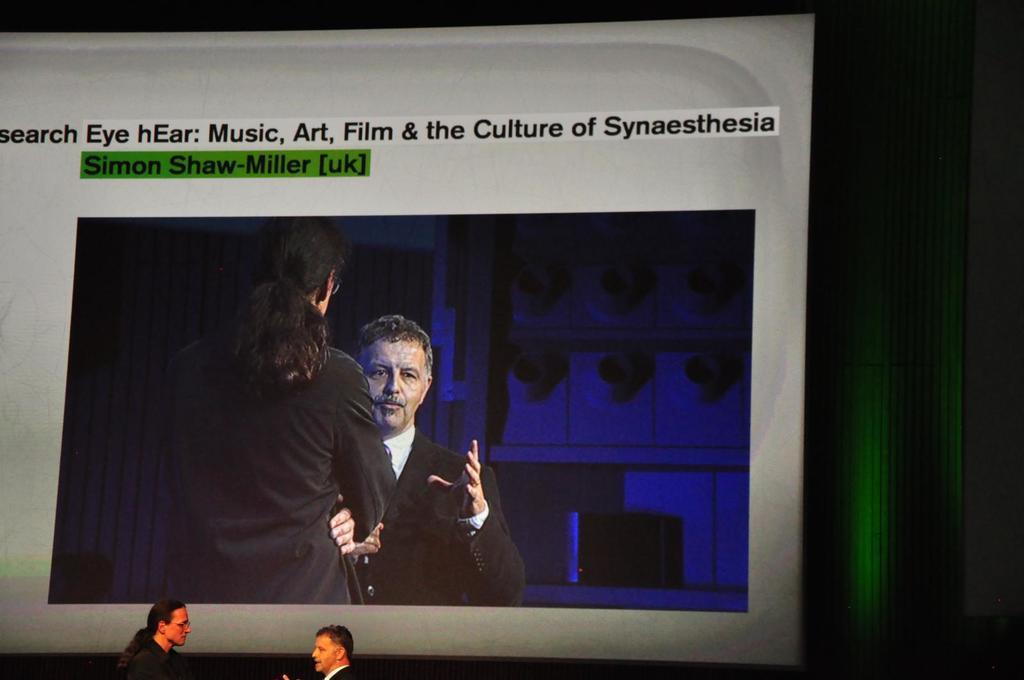Can you describe this image briefly? In this image we can see two people standing and talking and in the background, we can see the screen with two people and we can also see some text on the screen. 